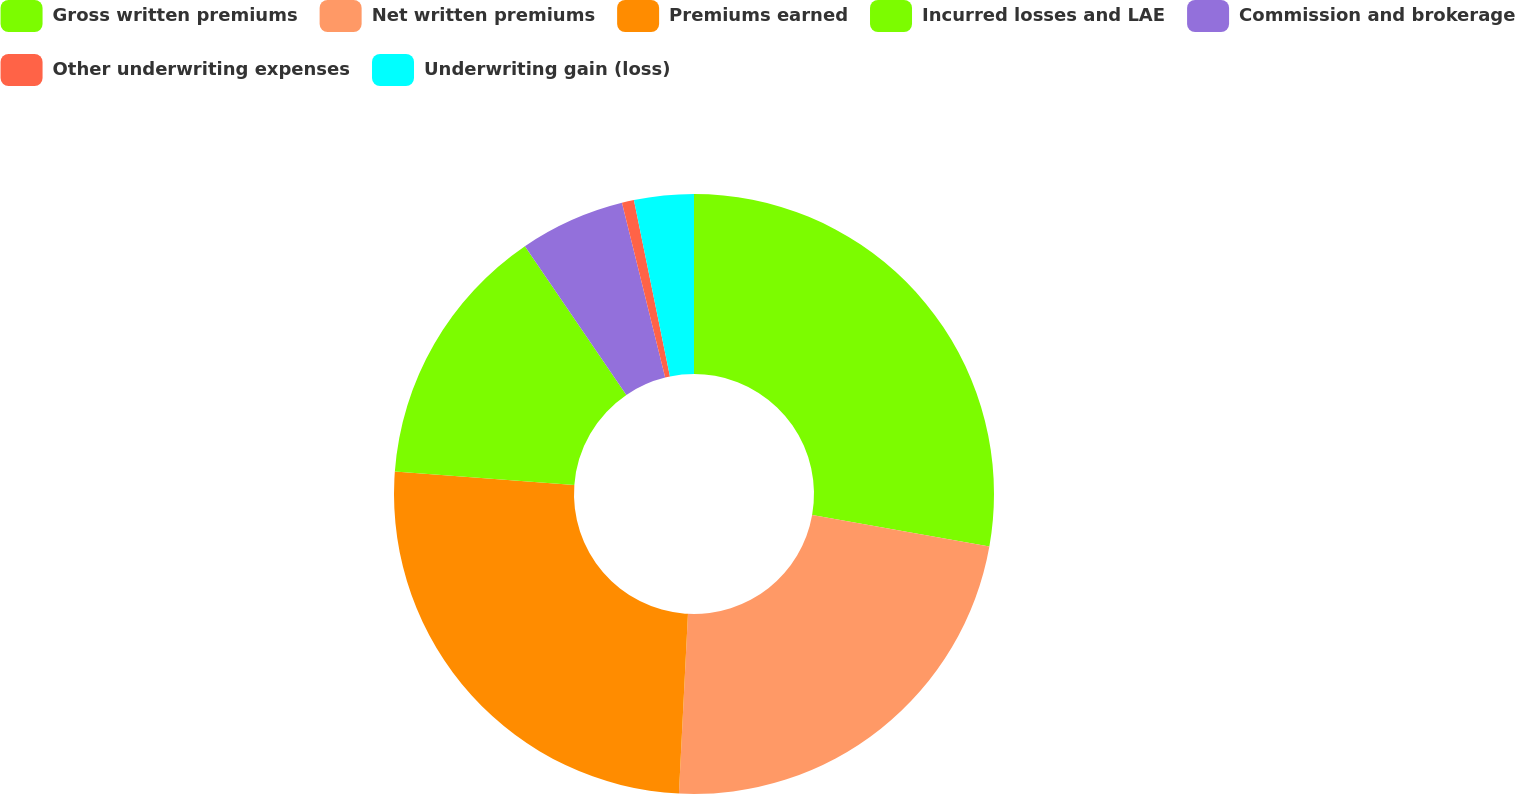Convert chart. <chart><loc_0><loc_0><loc_500><loc_500><pie_chart><fcel>Gross written premiums<fcel>Net written premiums<fcel>Premiums earned<fcel>Incurred losses and LAE<fcel>Commission and brokerage<fcel>Other underwriting expenses<fcel>Underwriting gain (loss)<nl><fcel>27.8%<fcel>23.0%<fcel>25.4%<fcel>14.27%<fcel>5.67%<fcel>0.65%<fcel>3.21%<nl></chart> 